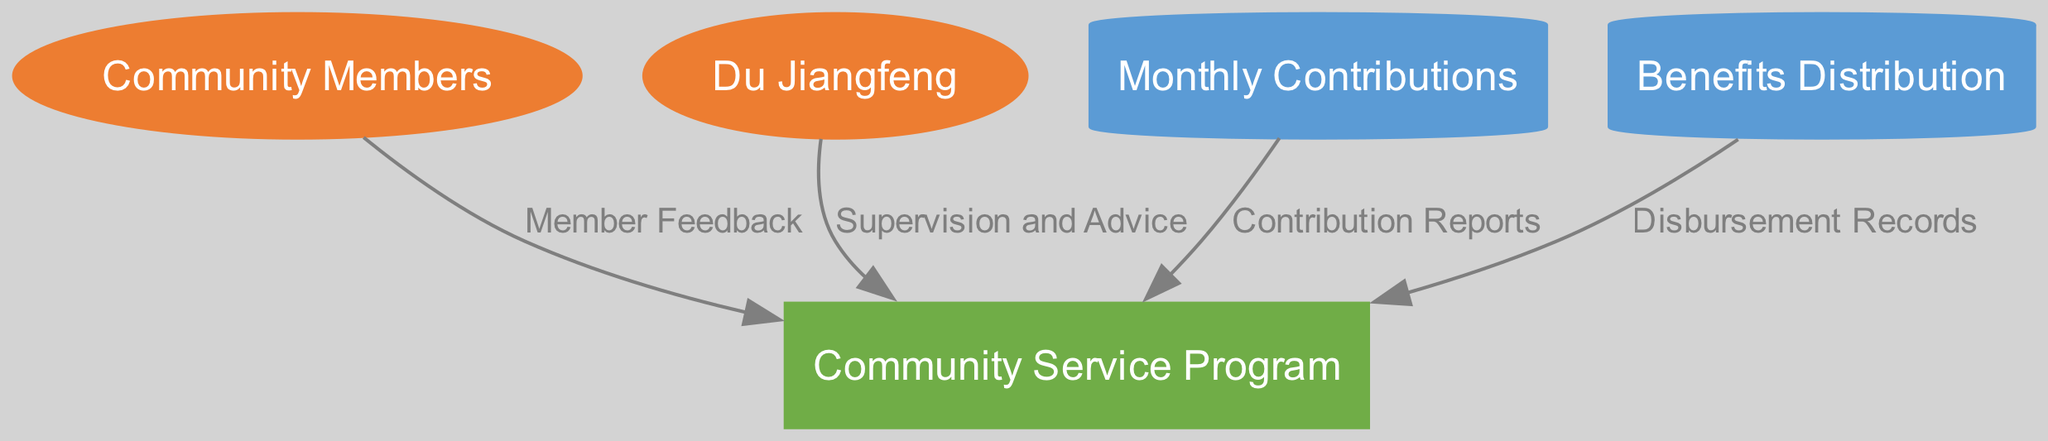What is the main process depicted in the diagram? The diagram identifies "Community Service Program" as the main process which organizes contributions and benefits.
Answer: Community Service Program Who provides guidance to ensure the program runs smoothly? The diagram shows that "Du Jiangfeng" supplies guidance as indicated by the data flow labeled "Supervision and Advice".
Answer: Du Jiangfeng What type of entity are "Community Members" categorized as? According to the diagram, "Community Members" are classified as "ExternalEntity", which refers to individuals outside the main process who interact with it.
Answer: ExternalEntity How many data stores are present in the diagram? The diagram contains two data stores: "Monthly Contributions" and "Benefits Distribution", thus there are two data stores.
Answer: 2 What is the purpose of the "Contribution Reports"? The "Contribution Reports" are generated from the "Monthly Contributions" data store which detail the contributions made by members.
Answer: Reports generated monthly on contributions What connects "Community Members" to the "Community Service Program"? "Member Feedback" connects "Community Members" to the "Community Service Program" as a data flow indicating communication from members to the program.
Answer: Member Feedback Which data store holds the records for benefits given to community members? The diagram specifies that the "Benefits Distribution" data store contains the details regarding benefits provided to members.
Answer: Benefits Distribution What flows from "Benefits Distribution" to "Community Service Program"? The "Disbursement Records" flow from "Benefits Distribution" to "Community Service Program", documented as how benefits are distributed.
Answer: Disbursement Records What role does the "Community Service Program" play in the contributions? The "Community Service Program" processes and organizes the contributions made by community members, according to the flow and structure of the diagram.
Answer: Main process 